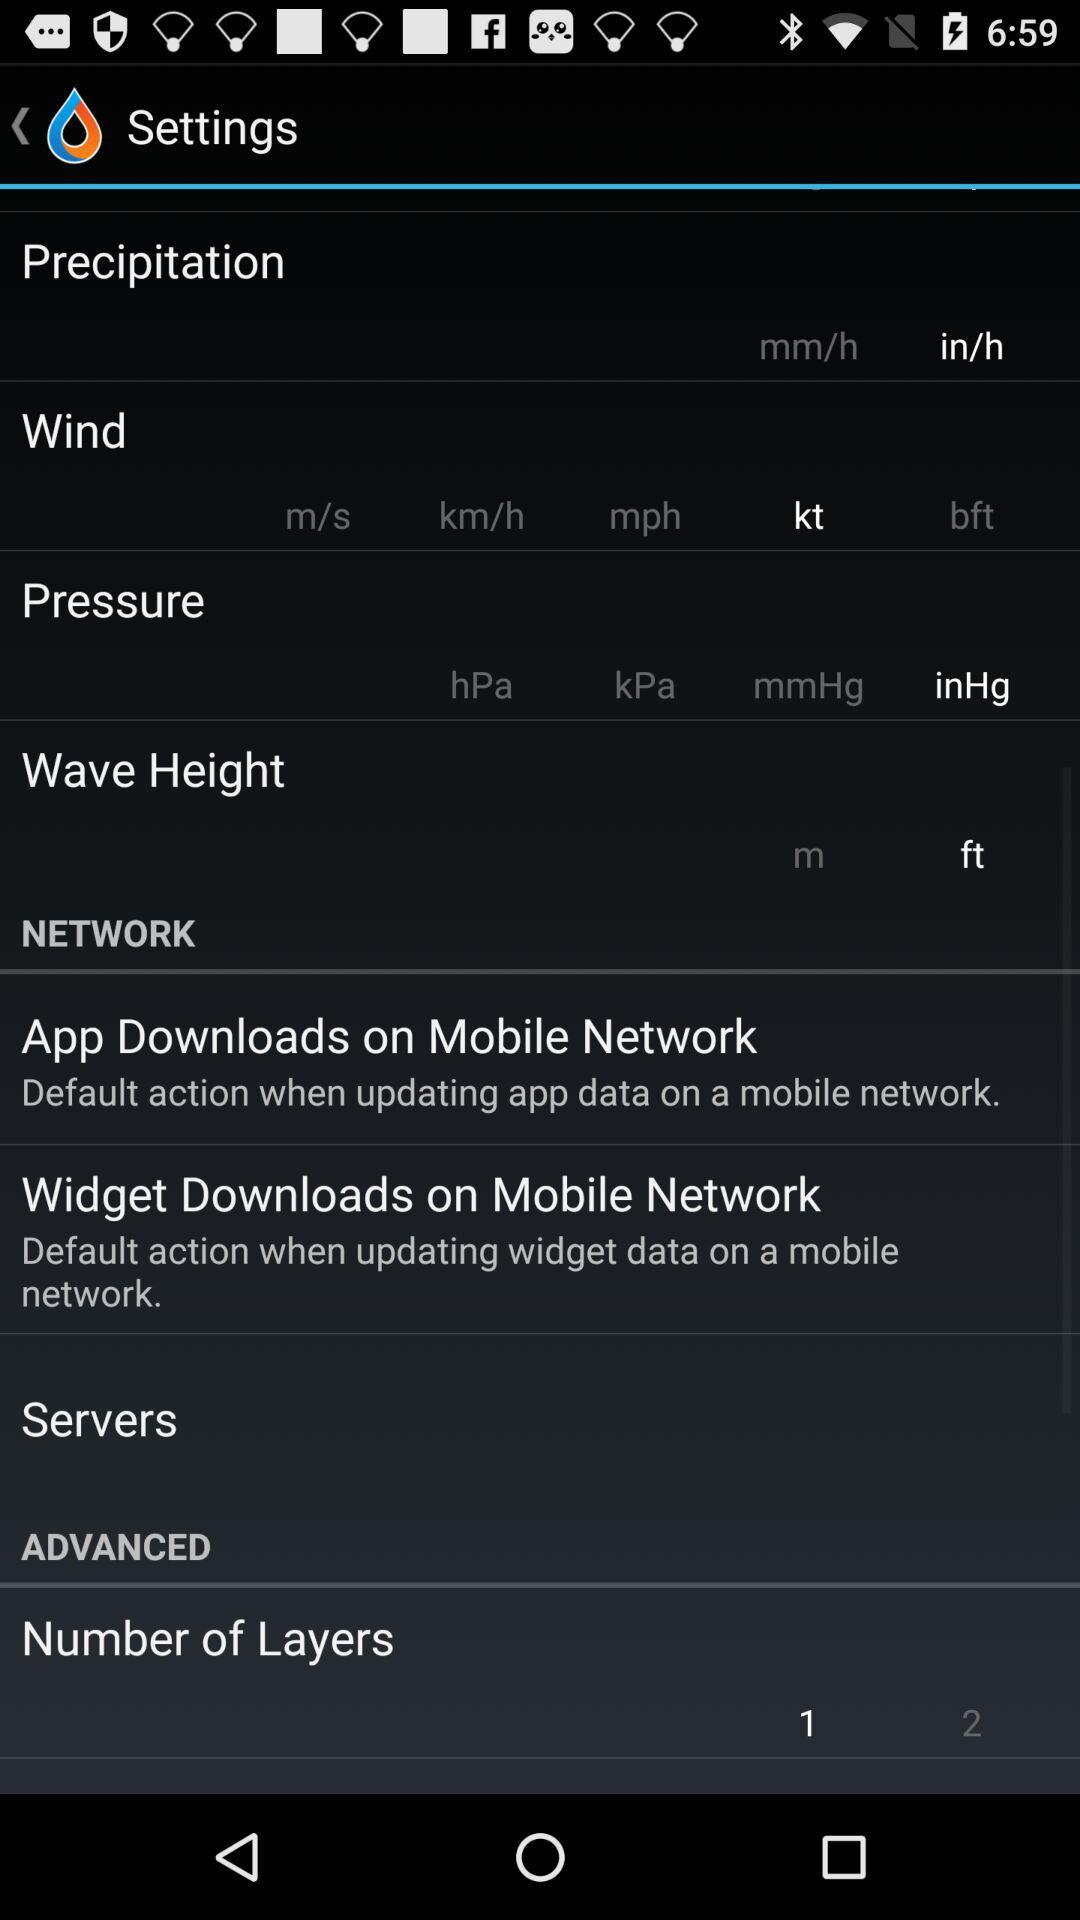What is the selected wave height unit? The selected wave height unit is ft. 